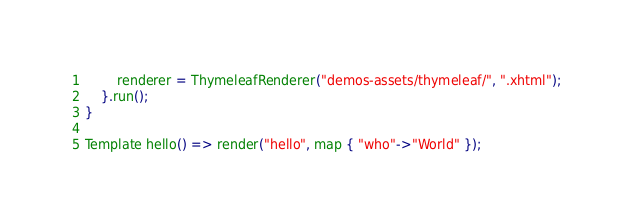<code> <loc_0><loc_0><loc_500><loc_500><_Ceylon_>        renderer = ThymeleafRenderer("demos-assets/thymeleaf/", ".xhtml");
    }.run();
}

Template hello() => render("hello", map { "who"->"World" });
</code> 